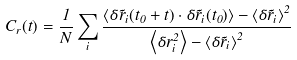Convert formula to latex. <formula><loc_0><loc_0><loc_500><loc_500>C _ { r } ( t ) = \frac { 1 } { N } \sum _ { i } \frac { \left < \delta \vec { r } _ { i } ( t _ { 0 } + t ) \cdot \delta \vec { r } _ { i } ( t _ { 0 } ) \right > - \left < \delta \vec { r } _ { i } \right > ^ { 2 } } { \left < \delta r _ { i } ^ { 2 } \right > - \left < \delta \vec { r } _ { i } \right > ^ { 2 } }</formula> 